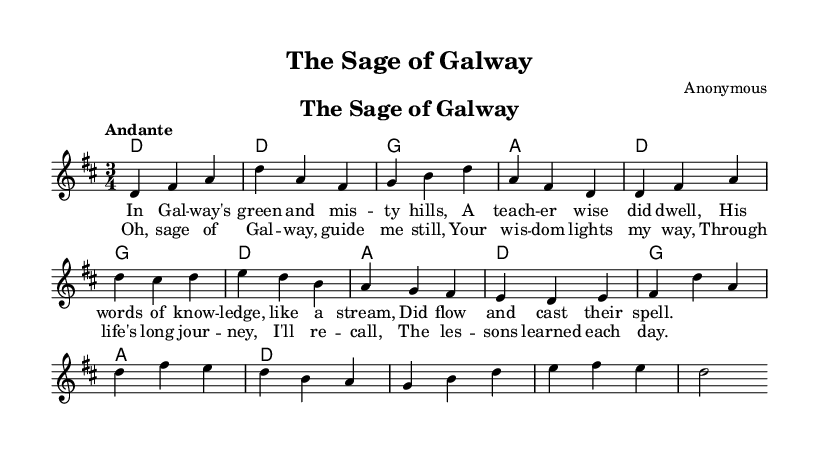What is the key signature of this music? The key signature is D major, which has two sharps (F# and C#) indicated in the music sheet.
Answer: D major What is the time signature of this piece? The time signature is 3/4, which means there are three beats in each measure and the quarter note gets one beat, as shown at the beginning of the score.
Answer: 3/4 What tempo marking is indicated in the score? The tempo marking is "Andante," which indicates a moderately slow tempo. This is clearly stated at the beginning of the piece.
Answer: Andante How many measures are in the chorus section? The chorus section consists of four measures, which can be counted by examining the lines dedicated to the chorus lyrics and their corresponding music notation.
Answer: 4 What is the title of this piece? The title of the piece is "The Sage of Galway," which is indicated at the top of the score.
Answer: The Sage of Galway What thematic element is central to the lyrics of this ballad? The central thematic element is the influence of a wise teacher, as expressed in the lyrics that narrate the teacher's wisdom and impact on the narrator's life.
Answer: Influence of a wise teacher What genre of music does this piece represent? This piece represents Celtic folk ballads, which are characterized by storytelling through music, often reflecting cultural themes like wisdom and guidance, as seen in the lyrics.
Answer: Celtic folk ballads 